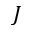<formula> <loc_0><loc_0><loc_500><loc_500>J</formula> 